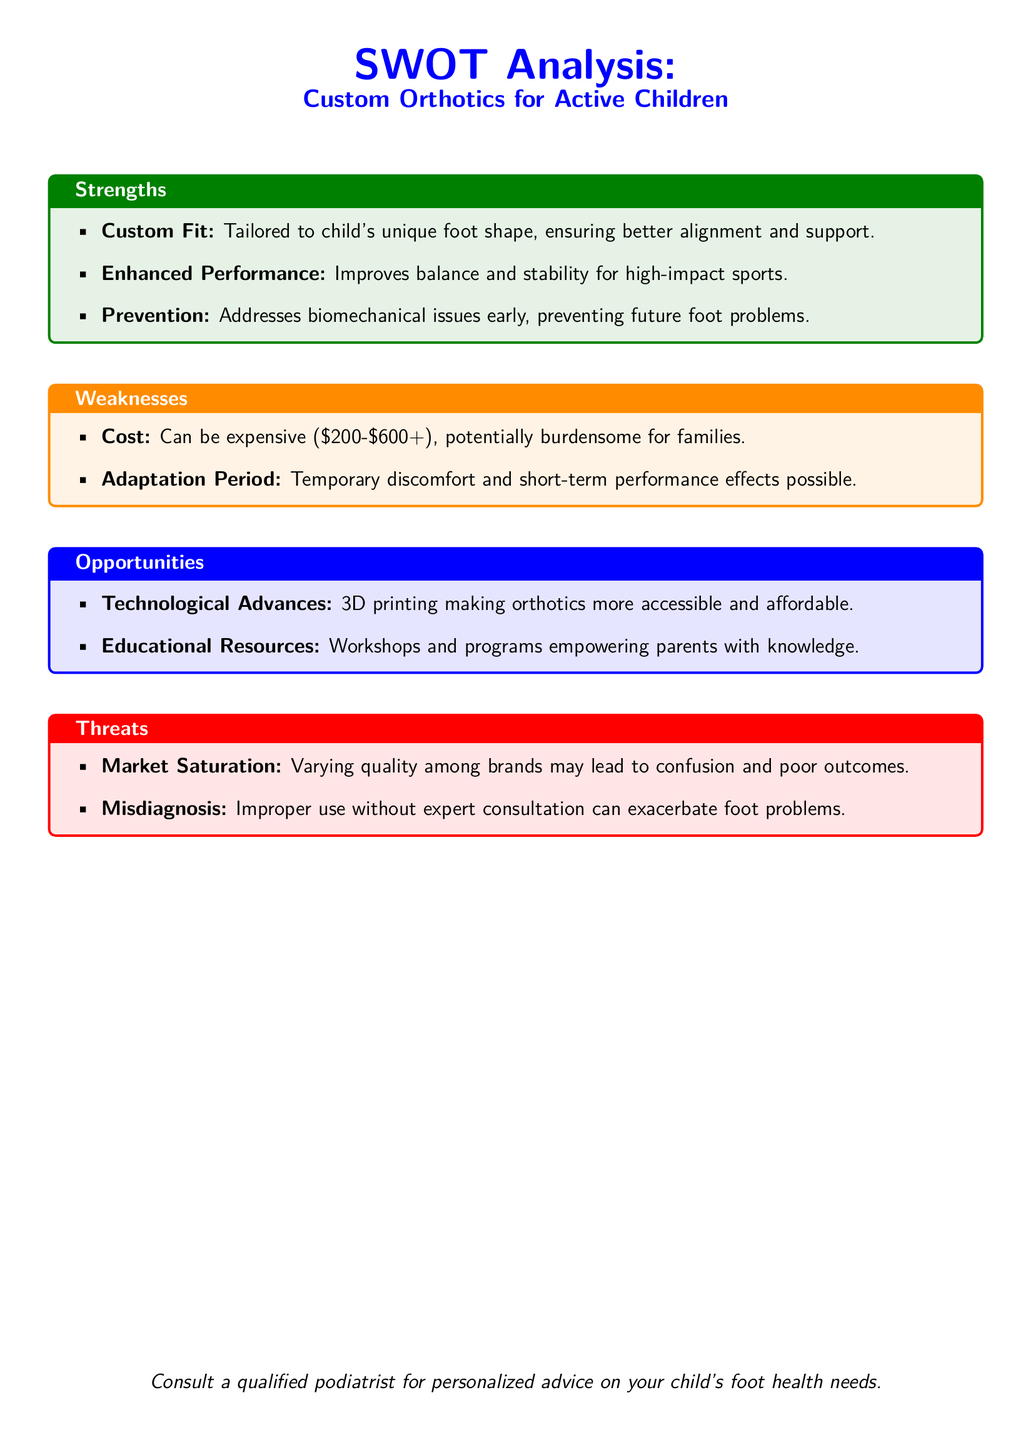What are the strengths of custom orthotics? The strengths are tailored fitting, enhanced performance, and prevention of foot problems.
Answer: Tailored fit, enhanced performance, prevention What is the cost range for custom orthotics? The document states that the cost can be expensive, with a range provided in the weaknesses section.
Answer: $200-$600+ What is one technological advance mentioned in the opportunities? The document lists 3D printing as a notable advancement in making orthotics more accessible.
Answer: 3D printing What is the main threat related to market saturation? The threat section indicates that varying quality among brands can lead to confusion and poor outcomes.
Answer: Confusion and poor outcomes What is a potential weakness of custom orthotics regarding adaptation? The document mentions that there may be temporary discomfort and short-term performance effects during the adaptation period.
Answer: Temporary discomfort What should parents do to ensure proper use of custom orthotics? The document recommends consulting a qualified podiatrist for personalized advice on foot health needs.
Answer: Consult a qualified podiatrist What educational resource is mentioned as an opportunity? Workshops and programs are identified as opportunities for empowering parents with knowledge.
Answer: Workshops and programs What is a biomechanical benefit of using custom orthotics for children? The strengths section highlights improved balance and stability for high-impact sports as a biomechanical benefit.
Answer: Improved balance and stability 